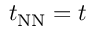<formula> <loc_0><loc_0><loc_500><loc_500>t _ { N N } = t</formula> 